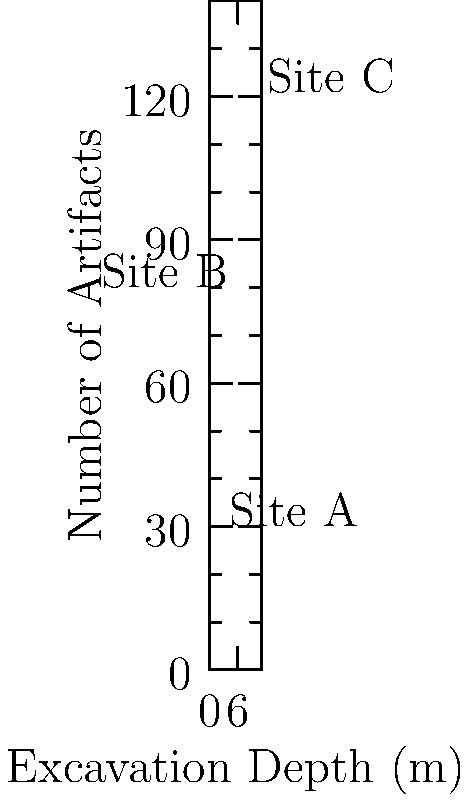Analyze the scatter plot depicting the distribution of artifacts across three archaeological sites (A, B, and C) at different excavation depths. Which site exhibits the steepest increase in artifact count relative to excavation depth, and what might this imply about the site's historical significance? To determine which site has the steepest increase in artifact count relative to excavation depth, we need to analyze the slope of each site's data points:

1. Calculate the slope for each site:
   Slope = (Change in Y) / (Change in X)

   Site A: (28 - 15) / (2 - 1) = 13
   Site B: (78 - 67) / (6 - 5) = 11
   Site C: (130 - 118) / (10 - 9) = 12

2. Compare the slopes:
   Site A has the steepest slope (13), followed by Site C (12), then Site B (11).

3. Interpretation:
   The steeper slope of Site A indicates a more rapid increase in artifact density per meter of excavation depth. This suggests:
   
   a) A shorter period of intense occupation or use
   b) Better preservation conditions
   c) A more concentrated deposition of artifacts

4. Historical significance:
   Site A's steeper slope might imply:
   
   a) A brief but important historical event or settlement
   b) A site with a specific, intensive purpose (e.g., a workshop or religious center)
   c) A location that experienced rapid abandonment, preserving a snapshot of a particular time

5. Comparative analysis:
   While Site A shows the most intense artifact concentration, Sites B and C demonstrate more gradual accumulation, potentially indicating:
   
   a) Longer periods of consistent occupation
   b) Slower cultural or technological changes
   c) Different site functions or importance over time
Answer: Site A; implies brief but intense occupation or rapid abandonment 